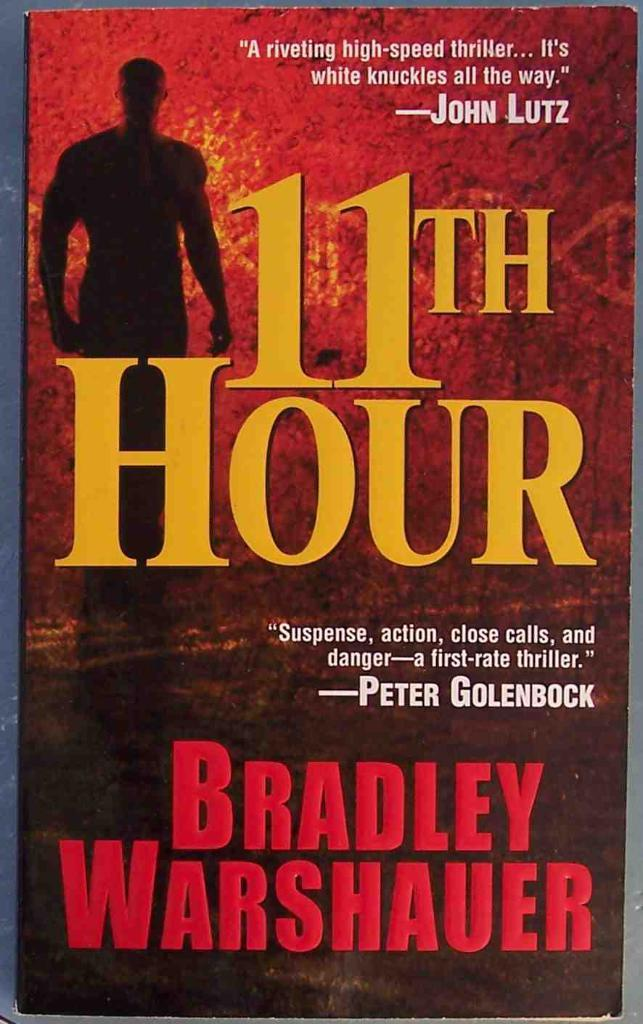<image>
Present a compact description of the photo's key features. A book called 11th hour was written by Bradley Warshauer. 